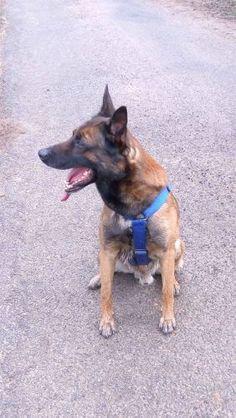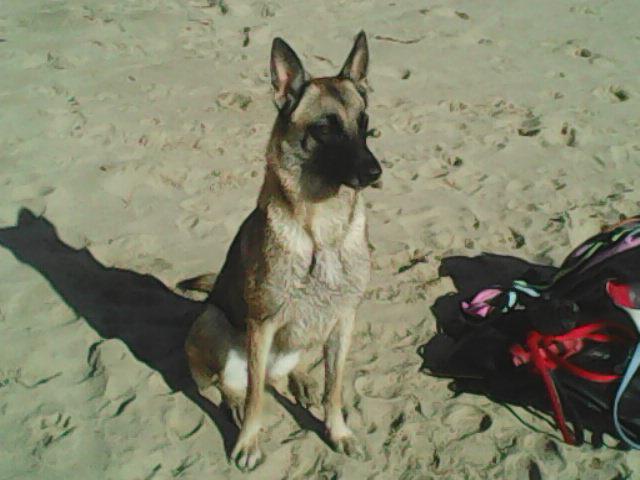The first image is the image on the left, the second image is the image on the right. For the images displayed, is the sentence "A dog with upright ears is bounding across the sand, and the ocean is visible in at least one image." factually correct? Answer yes or no. No. The first image is the image on the left, the second image is the image on the right. Analyze the images presented: Is the assertion "A single dog is standing legs and facing right in one of the images." valid? Answer yes or no. No. 